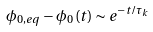<formula> <loc_0><loc_0><loc_500><loc_500>\phi _ { 0 , e q } - \phi _ { 0 } \left ( t \right ) \sim e ^ { - t / \tau _ { k } }</formula> 